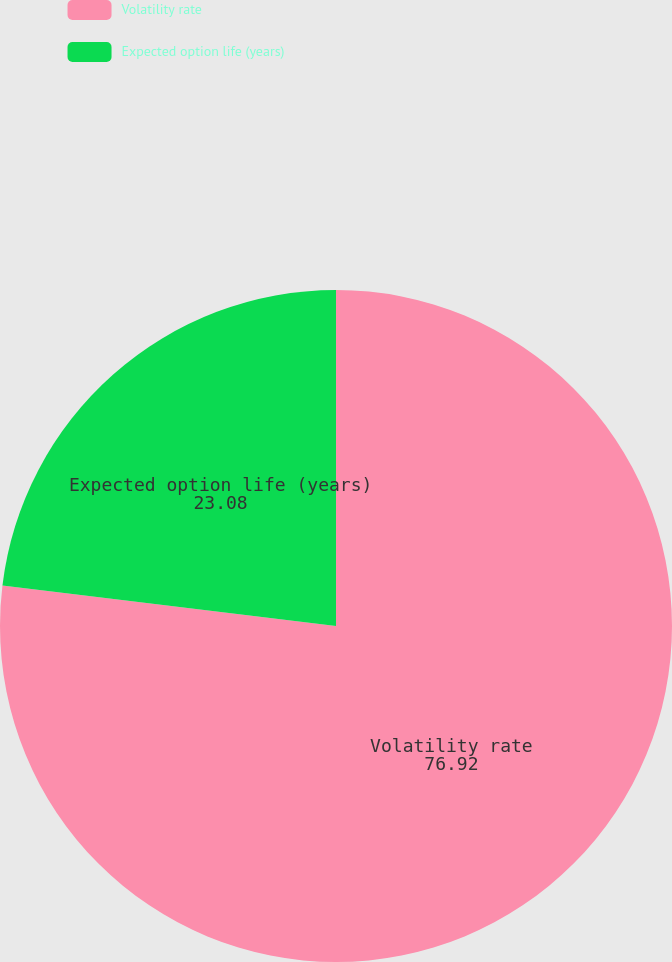Convert chart. <chart><loc_0><loc_0><loc_500><loc_500><pie_chart><fcel>Volatility rate<fcel>Expected option life (years)<nl><fcel>76.92%<fcel>23.08%<nl></chart> 